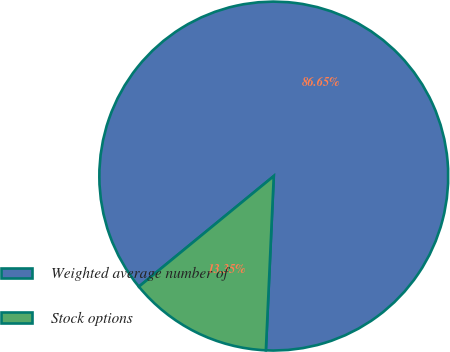Convert chart. <chart><loc_0><loc_0><loc_500><loc_500><pie_chart><fcel>Weighted average number of<fcel>Stock options<nl><fcel>86.65%<fcel>13.35%<nl></chart> 